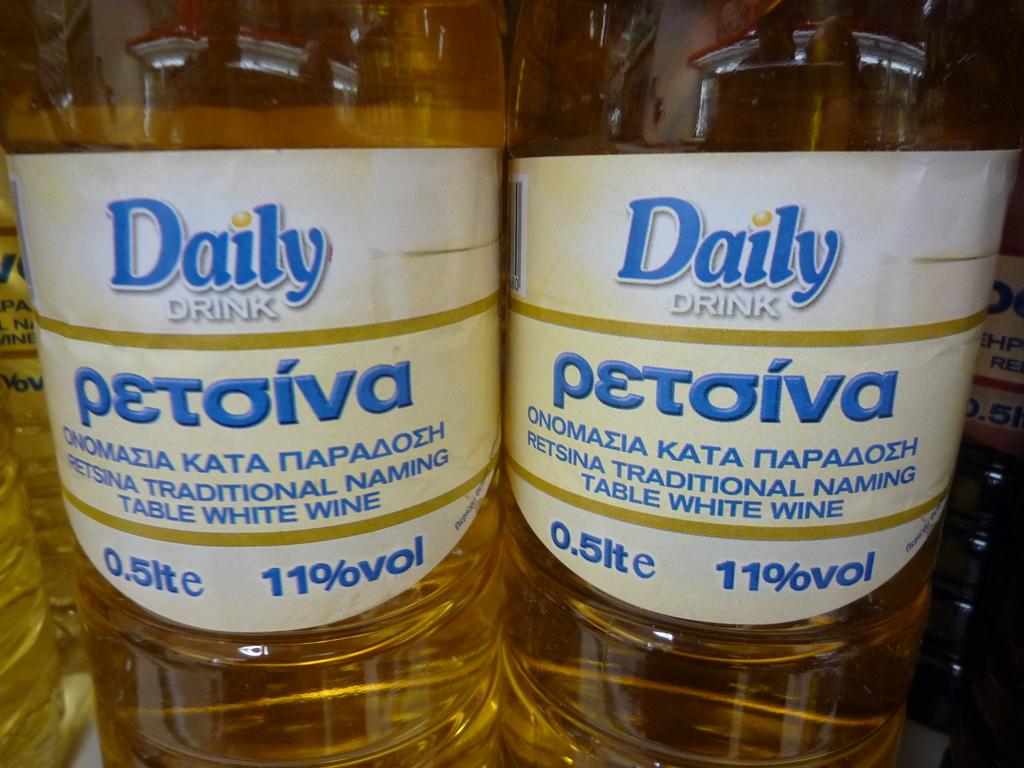What percentage volume is the drink?
Keep it short and to the point. 11%. What is the name of the drink?
Your answer should be compact. Petoiva. 